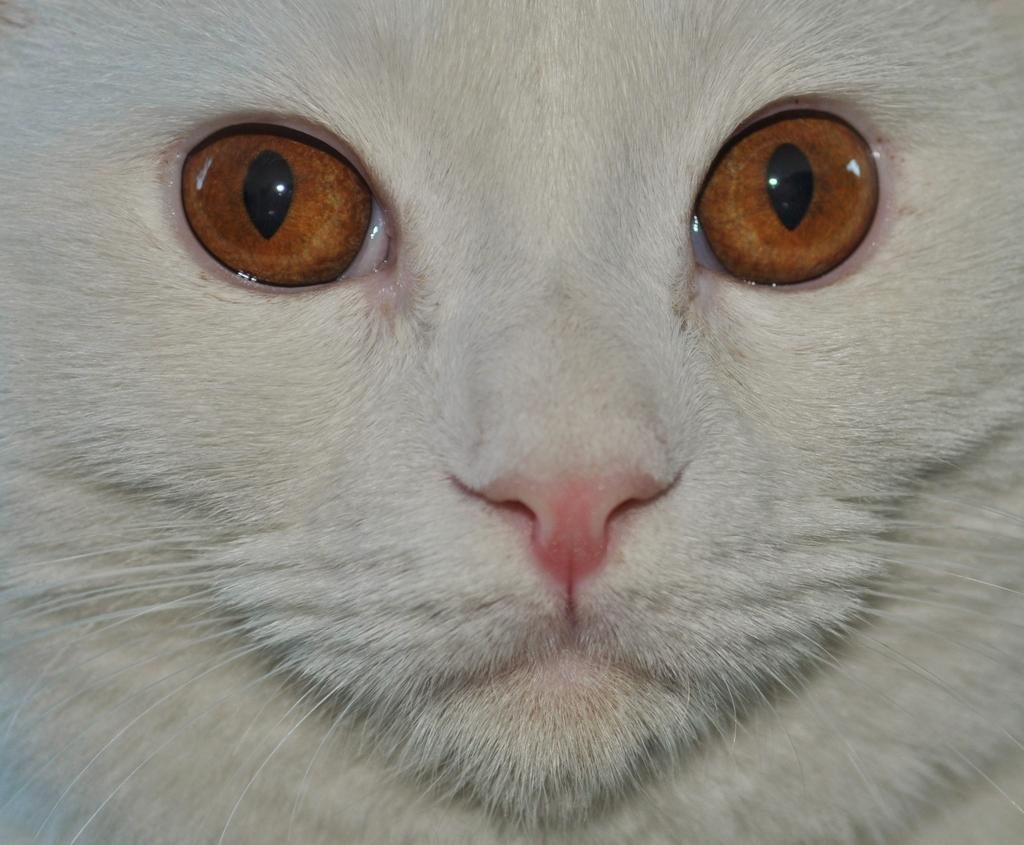Can you describe this image briefly? In this image, this looks like a cat, which is white in color. 